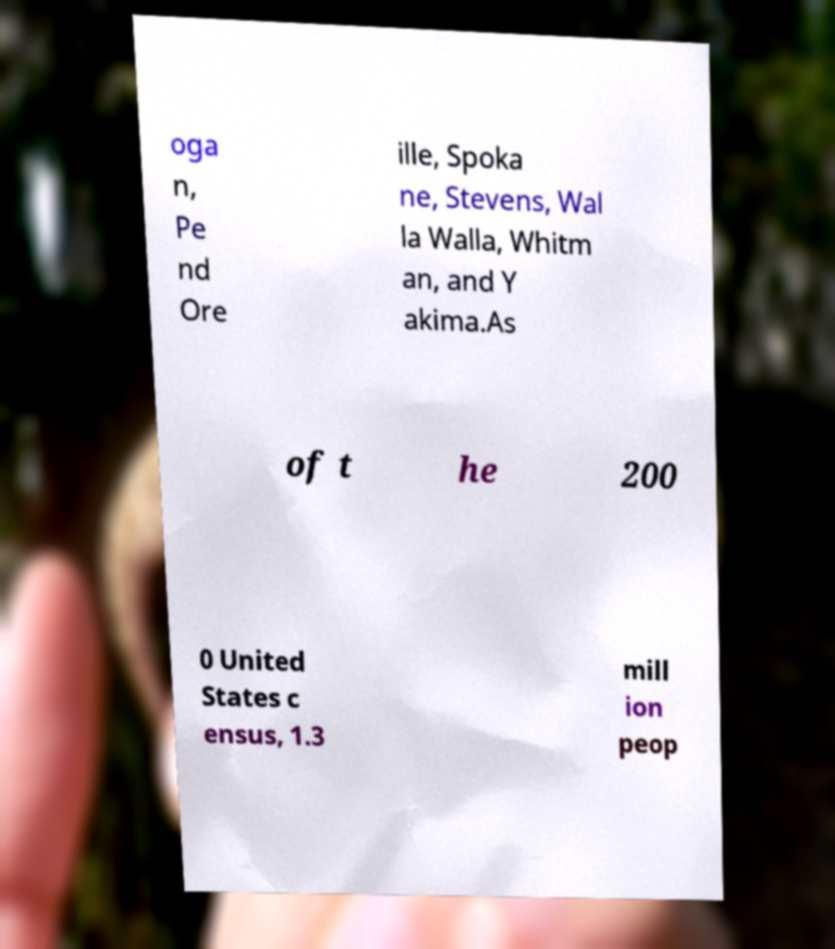Please read and relay the text visible in this image. What does it say? oga n, Pe nd Ore ille, Spoka ne, Stevens, Wal la Walla, Whitm an, and Y akima.As of t he 200 0 United States c ensus, 1.3 mill ion peop 